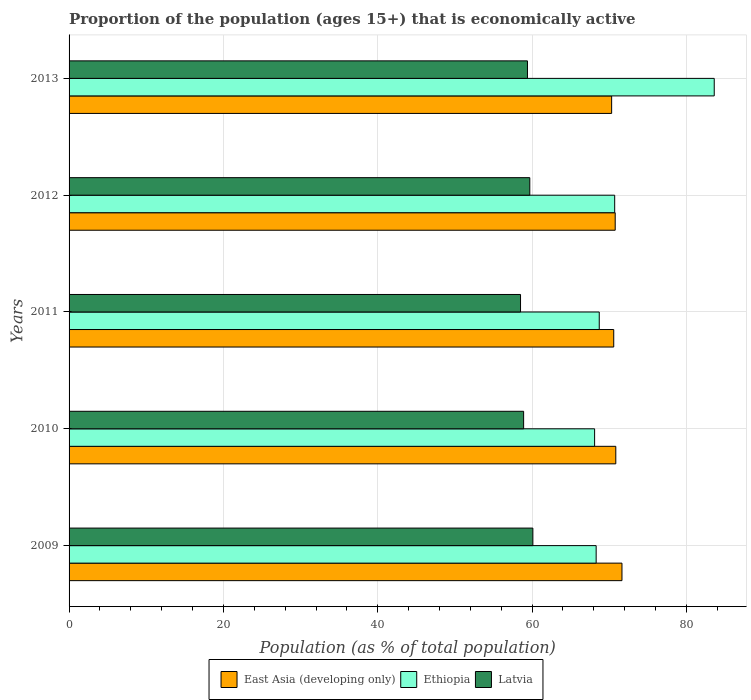Are the number of bars per tick equal to the number of legend labels?
Offer a very short reply. Yes. In how many cases, is the number of bars for a given year not equal to the number of legend labels?
Offer a very short reply. 0. What is the proportion of the population that is economically active in East Asia (developing only) in 2009?
Make the answer very short. 71.64. Across all years, what is the maximum proportion of the population that is economically active in Latvia?
Give a very brief answer. 60.1. Across all years, what is the minimum proportion of the population that is economically active in Ethiopia?
Give a very brief answer. 68.1. In which year was the proportion of the population that is economically active in East Asia (developing only) minimum?
Offer a terse response. 2013. What is the total proportion of the population that is economically active in Latvia in the graph?
Make the answer very short. 296.6. What is the difference between the proportion of the population that is economically active in Latvia in 2009 and that in 2010?
Offer a terse response. 1.2. What is the difference between the proportion of the population that is economically active in East Asia (developing only) in 2010 and the proportion of the population that is economically active in Latvia in 2011?
Make the answer very short. 12.34. What is the average proportion of the population that is economically active in Ethiopia per year?
Offer a very short reply. 71.88. In the year 2012, what is the difference between the proportion of the population that is economically active in East Asia (developing only) and proportion of the population that is economically active in Ethiopia?
Keep it short and to the point. 0.07. What is the ratio of the proportion of the population that is economically active in East Asia (developing only) in 2009 to that in 2010?
Offer a very short reply. 1.01. Is the proportion of the population that is economically active in Latvia in 2010 less than that in 2011?
Your answer should be very brief. No. What is the difference between the highest and the second highest proportion of the population that is economically active in Ethiopia?
Offer a terse response. 12.9. What is the difference between the highest and the lowest proportion of the population that is economically active in Ethiopia?
Offer a very short reply. 15.5. What does the 1st bar from the top in 2012 represents?
Offer a very short reply. Latvia. What does the 2nd bar from the bottom in 2012 represents?
Your answer should be compact. Ethiopia. Are all the bars in the graph horizontal?
Give a very brief answer. Yes. Are the values on the major ticks of X-axis written in scientific E-notation?
Keep it short and to the point. No. How are the legend labels stacked?
Provide a succinct answer. Horizontal. What is the title of the graph?
Provide a short and direct response. Proportion of the population (ages 15+) that is economically active. Does "Guatemala" appear as one of the legend labels in the graph?
Your response must be concise. No. What is the label or title of the X-axis?
Your answer should be very brief. Population (as % of total population). What is the Population (as % of total population) in East Asia (developing only) in 2009?
Your answer should be very brief. 71.64. What is the Population (as % of total population) in Ethiopia in 2009?
Provide a short and direct response. 68.3. What is the Population (as % of total population) in Latvia in 2009?
Your response must be concise. 60.1. What is the Population (as % of total population) in East Asia (developing only) in 2010?
Provide a short and direct response. 70.84. What is the Population (as % of total population) in Ethiopia in 2010?
Your answer should be very brief. 68.1. What is the Population (as % of total population) in Latvia in 2010?
Offer a terse response. 58.9. What is the Population (as % of total population) of East Asia (developing only) in 2011?
Give a very brief answer. 70.58. What is the Population (as % of total population) in Ethiopia in 2011?
Offer a terse response. 68.7. What is the Population (as % of total population) in Latvia in 2011?
Make the answer very short. 58.5. What is the Population (as % of total population) of East Asia (developing only) in 2012?
Provide a short and direct response. 70.77. What is the Population (as % of total population) of Ethiopia in 2012?
Provide a short and direct response. 70.7. What is the Population (as % of total population) of Latvia in 2012?
Make the answer very short. 59.7. What is the Population (as % of total population) in East Asia (developing only) in 2013?
Give a very brief answer. 70.31. What is the Population (as % of total population) in Ethiopia in 2013?
Make the answer very short. 83.6. What is the Population (as % of total population) of Latvia in 2013?
Give a very brief answer. 59.4. Across all years, what is the maximum Population (as % of total population) in East Asia (developing only)?
Your response must be concise. 71.64. Across all years, what is the maximum Population (as % of total population) in Ethiopia?
Provide a short and direct response. 83.6. Across all years, what is the maximum Population (as % of total population) in Latvia?
Provide a short and direct response. 60.1. Across all years, what is the minimum Population (as % of total population) of East Asia (developing only)?
Keep it short and to the point. 70.31. Across all years, what is the minimum Population (as % of total population) of Ethiopia?
Your answer should be compact. 68.1. Across all years, what is the minimum Population (as % of total population) of Latvia?
Offer a very short reply. 58.5. What is the total Population (as % of total population) in East Asia (developing only) in the graph?
Offer a terse response. 354.14. What is the total Population (as % of total population) in Ethiopia in the graph?
Your answer should be very brief. 359.4. What is the total Population (as % of total population) in Latvia in the graph?
Give a very brief answer. 296.6. What is the difference between the Population (as % of total population) in East Asia (developing only) in 2009 and that in 2010?
Your answer should be compact. 0.8. What is the difference between the Population (as % of total population) in Ethiopia in 2009 and that in 2010?
Offer a terse response. 0.2. What is the difference between the Population (as % of total population) in Latvia in 2009 and that in 2010?
Your response must be concise. 1.2. What is the difference between the Population (as % of total population) of East Asia (developing only) in 2009 and that in 2011?
Your response must be concise. 1.07. What is the difference between the Population (as % of total population) of Ethiopia in 2009 and that in 2011?
Provide a succinct answer. -0.4. What is the difference between the Population (as % of total population) in East Asia (developing only) in 2009 and that in 2012?
Provide a succinct answer. 0.88. What is the difference between the Population (as % of total population) in Ethiopia in 2009 and that in 2012?
Make the answer very short. -2.4. What is the difference between the Population (as % of total population) of East Asia (developing only) in 2009 and that in 2013?
Provide a succinct answer. 1.34. What is the difference between the Population (as % of total population) of Ethiopia in 2009 and that in 2013?
Your response must be concise. -15.3. What is the difference between the Population (as % of total population) of East Asia (developing only) in 2010 and that in 2011?
Ensure brevity in your answer.  0.27. What is the difference between the Population (as % of total population) in East Asia (developing only) in 2010 and that in 2012?
Your answer should be compact. 0.08. What is the difference between the Population (as % of total population) of Ethiopia in 2010 and that in 2012?
Your response must be concise. -2.6. What is the difference between the Population (as % of total population) of Latvia in 2010 and that in 2012?
Offer a very short reply. -0.8. What is the difference between the Population (as % of total population) of East Asia (developing only) in 2010 and that in 2013?
Make the answer very short. 0.54. What is the difference between the Population (as % of total population) of Ethiopia in 2010 and that in 2013?
Your answer should be very brief. -15.5. What is the difference between the Population (as % of total population) in East Asia (developing only) in 2011 and that in 2012?
Ensure brevity in your answer.  -0.19. What is the difference between the Population (as % of total population) of Ethiopia in 2011 and that in 2012?
Your answer should be compact. -2. What is the difference between the Population (as % of total population) in East Asia (developing only) in 2011 and that in 2013?
Offer a very short reply. 0.27. What is the difference between the Population (as % of total population) in Ethiopia in 2011 and that in 2013?
Your answer should be compact. -14.9. What is the difference between the Population (as % of total population) in East Asia (developing only) in 2012 and that in 2013?
Offer a terse response. 0.46. What is the difference between the Population (as % of total population) in East Asia (developing only) in 2009 and the Population (as % of total population) in Ethiopia in 2010?
Provide a short and direct response. 3.54. What is the difference between the Population (as % of total population) in East Asia (developing only) in 2009 and the Population (as % of total population) in Latvia in 2010?
Give a very brief answer. 12.74. What is the difference between the Population (as % of total population) in East Asia (developing only) in 2009 and the Population (as % of total population) in Ethiopia in 2011?
Provide a succinct answer. 2.94. What is the difference between the Population (as % of total population) in East Asia (developing only) in 2009 and the Population (as % of total population) in Latvia in 2011?
Offer a terse response. 13.14. What is the difference between the Population (as % of total population) in East Asia (developing only) in 2009 and the Population (as % of total population) in Ethiopia in 2012?
Provide a succinct answer. 0.94. What is the difference between the Population (as % of total population) in East Asia (developing only) in 2009 and the Population (as % of total population) in Latvia in 2012?
Offer a terse response. 11.94. What is the difference between the Population (as % of total population) in East Asia (developing only) in 2009 and the Population (as % of total population) in Ethiopia in 2013?
Offer a very short reply. -11.96. What is the difference between the Population (as % of total population) of East Asia (developing only) in 2009 and the Population (as % of total population) of Latvia in 2013?
Provide a short and direct response. 12.24. What is the difference between the Population (as % of total population) in East Asia (developing only) in 2010 and the Population (as % of total population) in Ethiopia in 2011?
Your response must be concise. 2.14. What is the difference between the Population (as % of total population) of East Asia (developing only) in 2010 and the Population (as % of total population) of Latvia in 2011?
Give a very brief answer. 12.34. What is the difference between the Population (as % of total population) in Ethiopia in 2010 and the Population (as % of total population) in Latvia in 2011?
Give a very brief answer. 9.6. What is the difference between the Population (as % of total population) in East Asia (developing only) in 2010 and the Population (as % of total population) in Ethiopia in 2012?
Your answer should be compact. 0.14. What is the difference between the Population (as % of total population) in East Asia (developing only) in 2010 and the Population (as % of total population) in Latvia in 2012?
Give a very brief answer. 11.14. What is the difference between the Population (as % of total population) of Ethiopia in 2010 and the Population (as % of total population) of Latvia in 2012?
Provide a succinct answer. 8.4. What is the difference between the Population (as % of total population) in East Asia (developing only) in 2010 and the Population (as % of total population) in Ethiopia in 2013?
Ensure brevity in your answer.  -12.76. What is the difference between the Population (as % of total population) of East Asia (developing only) in 2010 and the Population (as % of total population) of Latvia in 2013?
Your answer should be very brief. 11.44. What is the difference between the Population (as % of total population) of Ethiopia in 2010 and the Population (as % of total population) of Latvia in 2013?
Offer a very short reply. 8.7. What is the difference between the Population (as % of total population) of East Asia (developing only) in 2011 and the Population (as % of total population) of Ethiopia in 2012?
Offer a very short reply. -0.12. What is the difference between the Population (as % of total population) of East Asia (developing only) in 2011 and the Population (as % of total population) of Latvia in 2012?
Provide a short and direct response. 10.88. What is the difference between the Population (as % of total population) in East Asia (developing only) in 2011 and the Population (as % of total population) in Ethiopia in 2013?
Make the answer very short. -13.02. What is the difference between the Population (as % of total population) of East Asia (developing only) in 2011 and the Population (as % of total population) of Latvia in 2013?
Keep it short and to the point. 11.18. What is the difference between the Population (as % of total population) of Ethiopia in 2011 and the Population (as % of total population) of Latvia in 2013?
Keep it short and to the point. 9.3. What is the difference between the Population (as % of total population) in East Asia (developing only) in 2012 and the Population (as % of total population) in Ethiopia in 2013?
Offer a terse response. -12.83. What is the difference between the Population (as % of total population) in East Asia (developing only) in 2012 and the Population (as % of total population) in Latvia in 2013?
Provide a succinct answer. 11.37. What is the average Population (as % of total population) in East Asia (developing only) per year?
Your response must be concise. 70.83. What is the average Population (as % of total population) of Ethiopia per year?
Offer a terse response. 71.88. What is the average Population (as % of total population) in Latvia per year?
Offer a terse response. 59.32. In the year 2009, what is the difference between the Population (as % of total population) in East Asia (developing only) and Population (as % of total population) in Ethiopia?
Offer a very short reply. 3.34. In the year 2009, what is the difference between the Population (as % of total population) of East Asia (developing only) and Population (as % of total population) of Latvia?
Provide a succinct answer. 11.54. In the year 2010, what is the difference between the Population (as % of total population) in East Asia (developing only) and Population (as % of total population) in Ethiopia?
Keep it short and to the point. 2.74. In the year 2010, what is the difference between the Population (as % of total population) in East Asia (developing only) and Population (as % of total population) in Latvia?
Provide a short and direct response. 11.94. In the year 2011, what is the difference between the Population (as % of total population) in East Asia (developing only) and Population (as % of total population) in Ethiopia?
Your answer should be very brief. 1.88. In the year 2011, what is the difference between the Population (as % of total population) of East Asia (developing only) and Population (as % of total population) of Latvia?
Provide a succinct answer. 12.08. In the year 2011, what is the difference between the Population (as % of total population) of Ethiopia and Population (as % of total population) of Latvia?
Provide a short and direct response. 10.2. In the year 2012, what is the difference between the Population (as % of total population) of East Asia (developing only) and Population (as % of total population) of Ethiopia?
Offer a very short reply. 0.07. In the year 2012, what is the difference between the Population (as % of total population) of East Asia (developing only) and Population (as % of total population) of Latvia?
Your answer should be compact. 11.07. In the year 2012, what is the difference between the Population (as % of total population) of Ethiopia and Population (as % of total population) of Latvia?
Provide a short and direct response. 11. In the year 2013, what is the difference between the Population (as % of total population) of East Asia (developing only) and Population (as % of total population) of Ethiopia?
Offer a terse response. -13.29. In the year 2013, what is the difference between the Population (as % of total population) of East Asia (developing only) and Population (as % of total population) of Latvia?
Ensure brevity in your answer.  10.91. In the year 2013, what is the difference between the Population (as % of total population) in Ethiopia and Population (as % of total population) in Latvia?
Provide a short and direct response. 24.2. What is the ratio of the Population (as % of total population) in East Asia (developing only) in 2009 to that in 2010?
Give a very brief answer. 1.01. What is the ratio of the Population (as % of total population) of Latvia in 2009 to that in 2010?
Ensure brevity in your answer.  1.02. What is the ratio of the Population (as % of total population) of East Asia (developing only) in 2009 to that in 2011?
Your answer should be very brief. 1.02. What is the ratio of the Population (as % of total population) of Latvia in 2009 to that in 2011?
Provide a short and direct response. 1.03. What is the ratio of the Population (as % of total population) in East Asia (developing only) in 2009 to that in 2012?
Provide a short and direct response. 1.01. What is the ratio of the Population (as % of total population) in Ethiopia in 2009 to that in 2012?
Provide a short and direct response. 0.97. What is the ratio of the Population (as % of total population) of East Asia (developing only) in 2009 to that in 2013?
Your response must be concise. 1.02. What is the ratio of the Population (as % of total population) in Ethiopia in 2009 to that in 2013?
Provide a succinct answer. 0.82. What is the ratio of the Population (as % of total population) of Latvia in 2009 to that in 2013?
Offer a terse response. 1.01. What is the ratio of the Population (as % of total population) of East Asia (developing only) in 2010 to that in 2011?
Provide a succinct answer. 1. What is the ratio of the Population (as % of total population) of Latvia in 2010 to that in 2011?
Keep it short and to the point. 1.01. What is the ratio of the Population (as % of total population) of Ethiopia in 2010 to that in 2012?
Ensure brevity in your answer.  0.96. What is the ratio of the Population (as % of total population) of Latvia in 2010 to that in 2012?
Your answer should be very brief. 0.99. What is the ratio of the Population (as % of total population) in East Asia (developing only) in 2010 to that in 2013?
Your answer should be very brief. 1.01. What is the ratio of the Population (as % of total population) of Ethiopia in 2010 to that in 2013?
Ensure brevity in your answer.  0.81. What is the ratio of the Population (as % of total population) in Ethiopia in 2011 to that in 2012?
Keep it short and to the point. 0.97. What is the ratio of the Population (as % of total population) of Latvia in 2011 to that in 2012?
Offer a very short reply. 0.98. What is the ratio of the Population (as % of total population) of Ethiopia in 2011 to that in 2013?
Provide a succinct answer. 0.82. What is the ratio of the Population (as % of total population) of Latvia in 2011 to that in 2013?
Ensure brevity in your answer.  0.98. What is the ratio of the Population (as % of total population) in East Asia (developing only) in 2012 to that in 2013?
Keep it short and to the point. 1.01. What is the ratio of the Population (as % of total population) in Ethiopia in 2012 to that in 2013?
Your response must be concise. 0.85. What is the ratio of the Population (as % of total population) of Latvia in 2012 to that in 2013?
Ensure brevity in your answer.  1.01. What is the difference between the highest and the second highest Population (as % of total population) in Ethiopia?
Make the answer very short. 12.9. What is the difference between the highest and the second highest Population (as % of total population) of Latvia?
Provide a short and direct response. 0.4. What is the difference between the highest and the lowest Population (as % of total population) of East Asia (developing only)?
Ensure brevity in your answer.  1.34. What is the difference between the highest and the lowest Population (as % of total population) of Ethiopia?
Your answer should be very brief. 15.5. 